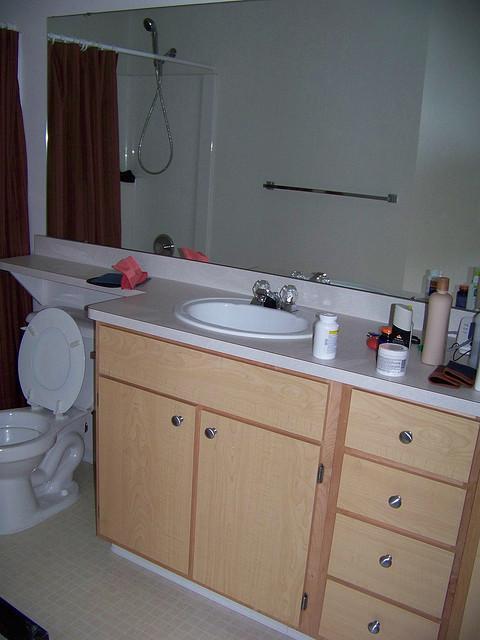How many drawers are there?
Give a very brief answer. 4. 